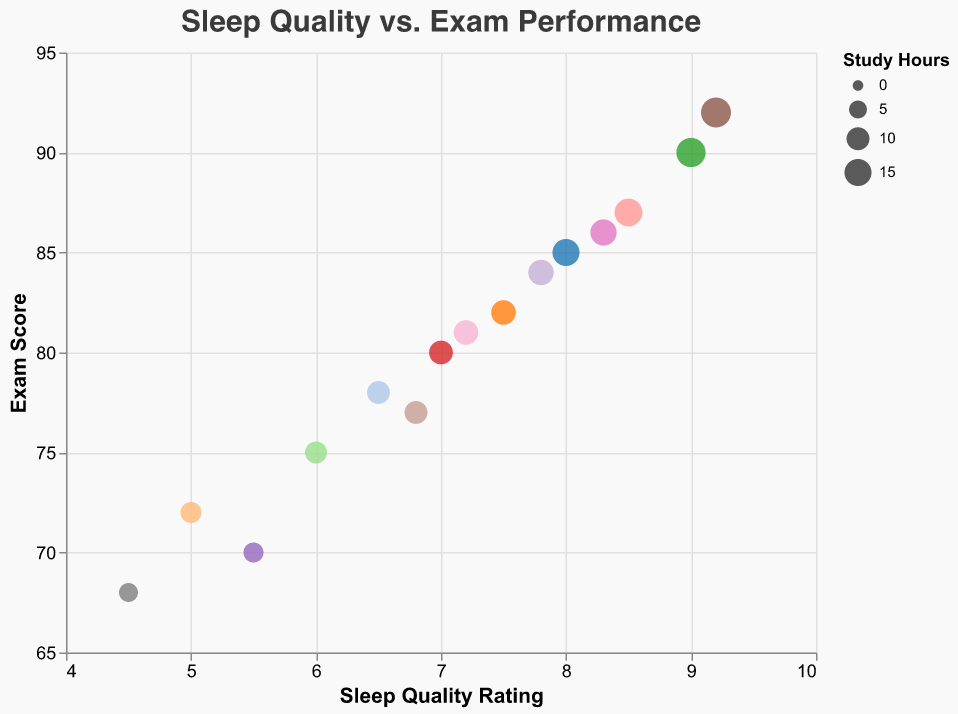What does the title of the chart read? The title is located at the top of the chart and indicates the main subject of the visualization, which is "Sleep Quality vs. Exam Performance."
Answer: Sleep Quality vs. Exam Performance What are the units on the x-axis? The x-axis represents the Sleep Quality Rating, which ranges from 4 to 10.
Answer: Sleep Quality Rating How many students are represented in the chart? Each circle in the bubble chart represents one student. By counting the number of distinct data points or circles, we can find the total number of students. There are 15 circles, indicating 15 students.
Answer: 15 Which student has the highest Exam Score? By examining the y-axis for the highest Exam Score and identifying the corresponding data point, we see that the student with the highest score is associated with an Exam Score of 92. The tooltip reveals the student's name as Karen Robinson.
Answer: Karen Robinson What's the average Sleep Quality Rating for students who scored above 85 on the exam? First, identify the data points where Exam Scores are greater than 85 (Eva Davis: 9.0, Henry Wilson: 8.5, Karen Robinson: 9.2, Monica Rodriguez: 8.3). Calculate the average Sleep Quality Rating by summing these ratings and dividing by the number of students: (9.0 + 8.5 + 9.2 + 8.3) / 4 = 35 / 4 = 8.75.
Answer: 8.75 Which student has the least number of Study Hours and what is their Exam Score? Find the smallest circle in the chart, representing the minimum number of Study Hours, and read the tooltip for the corresponding Exam Score. Ivy Garcia has the least number of Study Hours (7), and her Exam Score is 70.
Answer: Ivy Garcia, 70 Compare the Sleep Quality Ratings between the student who studied the most and the student who studied the least. The student with the most Study Hours is Karen Robinson (19 hours) with a Sleep Quality Rating of 9.2. The student with the least Study Hours is Ivy Garcia (7 hours) with a Sleep Quality Rating of 5.5.
Answer: Karen Robinson: 9.2, Ivy Garcia: 5.5 Is there a general trend between Sleep Quality Rating and Exam Score? By visually examining the data points, we observe that students with higher Sleep Quality Ratings tend to have higher Exam Scores, suggesting a positive correlation.
Answer: Positive correlation Which student has a similar Sleep Quality Rating to 7.5 but a significantly higher Exam Score? Determine the data points with a Sleep Quality Rating close to 7.5 and compare their Exam Scores. Carol Wang has a Sleep Quality Rating of 7.5 and an Exam Score of 82. Jack Martinez has a similar Sleep Quality Rating of 7.8 but a significantly higher Exam Score of 84.
Answer: Jack Martinez What's the range of Study Hours depicted in the chart? Examine the tooltip information and find the minimum and maximum values for Study Hours. The smallest is 6 hours (Olivia Hall) and the largest is 19 hours (Karen Robinson), giving us a range of 19 - 6 = 13 hours.
Answer: 13 hours 